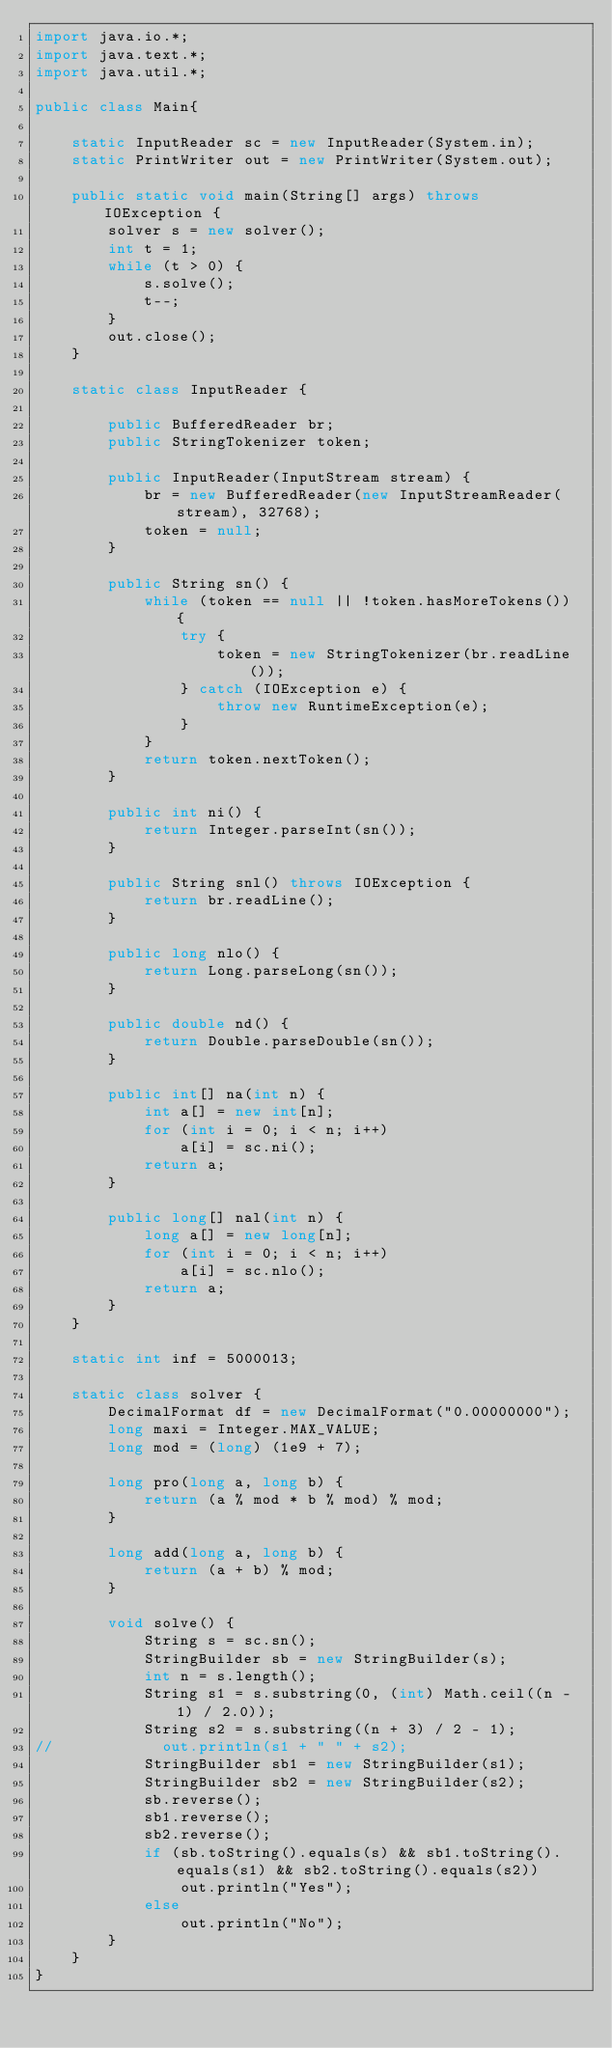Convert code to text. <code><loc_0><loc_0><loc_500><loc_500><_Java_>import java.io.*;
import java.text.*;
import java.util.*;

public class Main{

    static InputReader sc = new InputReader(System.in);
    static PrintWriter out = new PrintWriter(System.out);

    public static void main(String[] args) throws IOException {
        solver s = new solver();
        int t = 1;
        while (t > 0) {
            s.solve();
            t--;
        }
        out.close();
    }

    static class InputReader {

        public BufferedReader br;
        public StringTokenizer token;

        public InputReader(InputStream stream) {
            br = new BufferedReader(new InputStreamReader(stream), 32768);
            token = null;
        }

        public String sn() {
            while (token == null || !token.hasMoreTokens()) {
                try {
                    token = new StringTokenizer(br.readLine());
                } catch (IOException e) {
                    throw new RuntimeException(e);
                }
            }
            return token.nextToken();
        }

        public int ni() {
            return Integer.parseInt(sn());
        }

        public String snl() throws IOException {
            return br.readLine();
        }

        public long nlo() {
            return Long.parseLong(sn());
        }

        public double nd() {
            return Double.parseDouble(sn());
        }

        public int[] na(int n) {
            int a[] = new int[n];
            for (int i = 0; i < n; i++)
                a[i] = sc.ni();
            return a;
        }

        public long[] nal(int n) {
            long a[] = new long[n];
            for (int i = 0; i < n; i++)
                a[i] = sc.nlo();
            return a;
        }
    }

    static int inf = 5000013;

    static class solver {
        DecimalFormat df = new DecimalFormat("0.00000000");
        long maxi = Integer.MAX_VALUE;
        long mod = (long) (1e9 + 7);

        long pro(long a, long b) {
            return (a % mod * b % mod) % mod;
        }

        long add(long a, long b) {
            return (a + b) % mod;
        }

        void solve() {
            String s = sc.sn();
            StringBuilder sb = new StringBuilder(s);
            int n = s.length();
            String s1 = s.substring(0, (int) Math.ceil((n - 1) / 2.0));
            String s2 = s.substring((n + 3) / 2 - 1);
//            out.println(s1 + " " + s2);
            StringBuilder sb1 = new StringBuilder(s1);
            StringBuilder sb2 = new StringBuilder(s2);
            sb.reverse();
            sb1.reverse();
            sb2.reverse();
            if (sb.toString().equals(s) && sb1.toString().equals(s1) && sb2.toString().equals(s2))
                out.println("Yes");
            else
                out.println("No");
        }
    }
}
</code> 